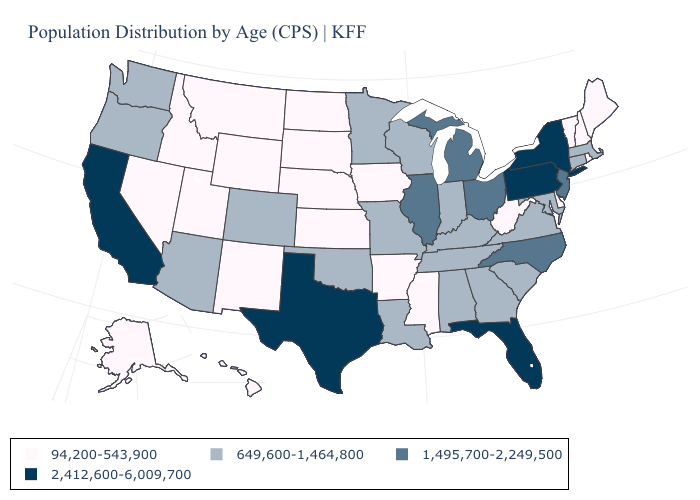What is the value of New York?
Write a very short answer. 2,412,600-6,009,700. Name the states that have a value in the range 94,200-543,900?
Concise answer only. Alaska, Arkansas, Delaware, Hawaii, Idaho, Iowa, Kansas, Maine, Mississippi, Montana, Nebraska, Nevada, New Hampshire, New Mexico, North Dakota, Rhode Island, South Dakota, Utah, Vermont, West Virginia, Wyoming. What is the highest value in the USA?
Give a very brief answer. 2,412,600-6,009,700. Name the states that have a value in the range 1,495,700-2,249,500?
Keep it brief. Illinois, Michigan, New Jersey, North Carolina, Ohio. Does Maryland have the highest value in the South?
Be succinct. No. Does Oregon have a higher value than Wyoming?
Write a very short answer. Yes. Name the states that have a value in the range 94,200-543,900?
Keep it brief. Alaska, Arkansas, Delaware, Hawaii, Idaho, Iowa, Kansas, Maine, Mississippi, Montana, Nebraska, Nevada, New Hampshire, New Mexico, North Dakota, Rhode Island, South Dakota, Utah, Vermont, West Virginia, Wyoming. What is the value of Arizona?
Write a very short answer. 649,600-1,464,800. Name the states that have a value in the range 1,495,700-2,249,500?
Concise answer only. Illinois, Michigan, New Jersey, North Carolina, Ohio. Among the states that border Nebraska , which have the highest value?
Keep it brief. Colorado, Missouri. Does Missouri have the highest value in the MidWest?
Answer briefly. No. What is the value of Oregon?
Answer briefly. 649,600-1,464,800. What is the value of Vermont?
Quick response, please. 94,200-543,900. Is the legend a continuous bar?
Give a very brief answer. No. Does Wyoming have the lowest value in the USA?
Answer briefly. Yes. 